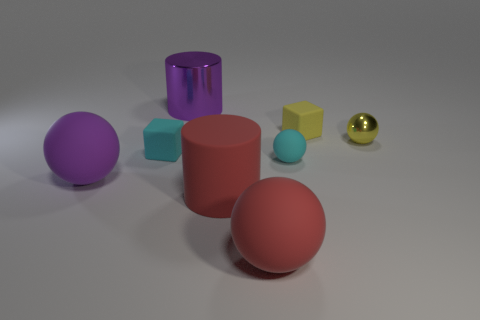Are there more big purple things that are to the right of the big red matte cylinder than gray metallic objects?
Provide a short and direct response. No. What number of other objects are there of the same material as the red cylinder?
Make the answer very short. 5. How many small things are brown matte blocks or cylinders?
Give a very brief answer. 0. Is the material of the purple cylinder the same as the cyan ball?
Provide a succinct answer. No. There is a cyan rubber cube to the left of the cyan matte ball; what number of large rubber cylinders are to the right of it?
Your answer should be compact. 1. Is there a small red metallic object of the same shape as the big purple matte thing?
Offer a terse response. No. There is a shiny thing behind the yellow metallic object; does it have the same shape as the big object that is in front of the large red matte cylinder?
Provide a succinct answer. No. The small matte object that is both on the right side of the big red rubber sphere and in front of the tiny yellow rubber object has what shape?
Your answer should be compact. Sphere. Is there a object that has the same size as the purple ball?
Your answer should be compact. Yes. Do the tiny matte sphere and the tiny object that is left of the purple metal cylinder have the same color?
Ensure brevity in your answer.  Yes. 